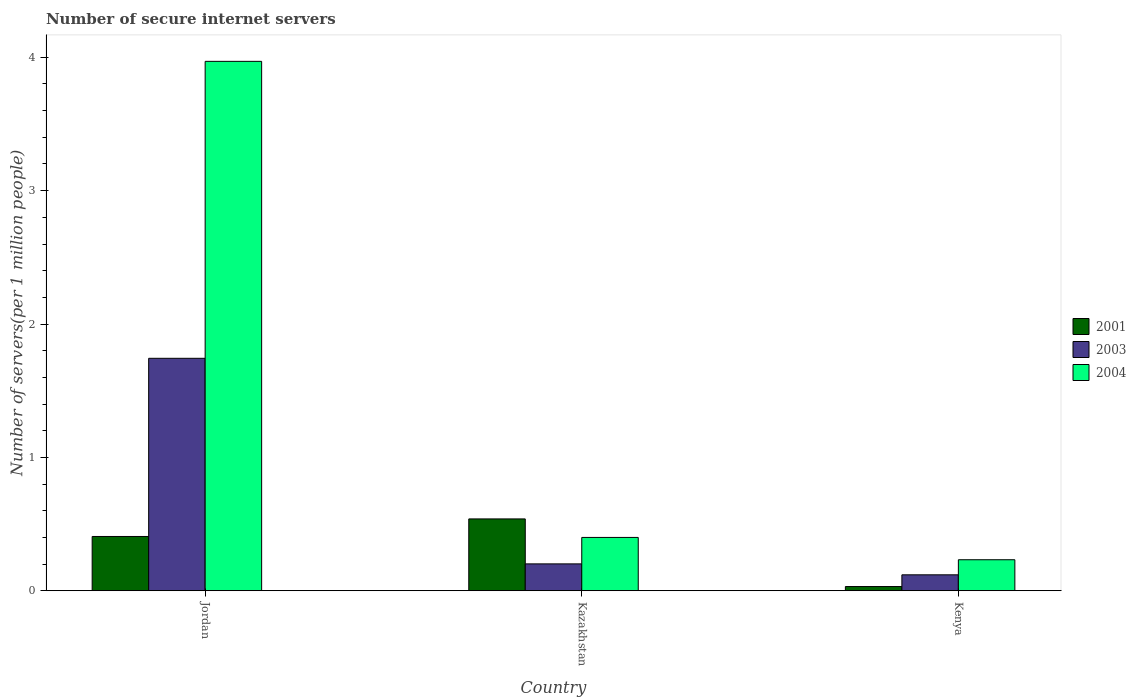How many groups of bars are there?
Your answer should be compact. 3. Are the number of bars on each tick of the X-axis equal?
Your answer should be compact. Yes. How many bars are there on the 2nd tick from the left?
Keep it short and to the point. 3. What is the label of the 1st group of bars from the left?
Provide a short and direct response. Jordan. What is the number of secure internet servers in 2004 in Kenya?
Provide a succinct answer. 0.23. Across all countries, what is the maximum number of secure internet servers in 2003?
Your answer should be compact. 1.74. Across all countries, what is the minimum number of secure internet servers in 2004?
Give a very brief answer. 0.23. In which country was the number of secure internet servers in 2003 maximum?
Your answer should be compact. Jordan. In which country was the number of secure internet servers in 2001 minimum?
Your response must be concise. Kenya. What is the total number of secure internet servers in 2003 in the graph?
Give a very brief answer. 2.06. What is the difference between the number of secure internet servers in 2004 in Jordan and that in Kenya?
Offer a terse response. 3.74. What is the difference between the number of secure internet servers in 2003 in Kenya and the number of secure internet servers in 2004 in Kazakhstan?
Your answer should be compact. -0.28. What is the average number of secure internet servers in 2003 per country?
Make the answer very short. 0.69. What is the difference between the number of secure internet servers of/in 2004 and number of secure internet servers of/in 2003 in Kazakhstan?
Provide a short and direct response. 0.2. What is the ratio of the number of secure internet servers in 2001 in Jordan to that in Kazakhstan?
Provide a succinct answer. 0.76. Is the difference between the number of secure internet servers in 2004 in Jordan and Kazakhstan greater than the difference between the number of secure internet servers in 2003 in Jordan and Kazakhstan?
Your response must be concise. Yes. What is the difference between the highest and the second highest number of secure internet servers in 2004?
Give a very brief answer. -3.57. What is the difference between the highest and the lowest number of secure internet servers in 2004?
Give a very brief answer. 3.74. Is it the case that in every country, the sum of the number of secure internet servers in 2004 and number of secure internet servers in 2001 is greater than the number of secure internet servers in 2003?
Provide a short and direct response. Yes. Are all the bars in the graph horizontal?
Provide a succinct answer. No. How many countries are there in the graph?
Offer a terse response. 3. What is the difference between two consecutive major ticks on the Y-axis?
Provide a short and direct response. 1. Does the graph contain any zero values?
Provide a short and direct response. No. Where does the legend appear in the graph?
Offer a very short reply. Center right. How are the legend labels stacked?
Your answer should be compact. Vertical. What is the title of the graph?
Ensure brevity in your answer.  Number of secure internet servers. What is the label or title of the Y-axis?
Offer a very short reply. Number of servers(per 1 million people). What is the Number of servers(per 1 million people) of 2001 in Jordan?
Provide a short and direct response. 0.41. What is the Number of servers(per 1 million people) in 2003 in Jordan?
Offer a very short reply. 1.74. What is the Number of servers(per 1 million people) in 2004 in Jordan?
Your answer should be very brief. 3.97. What is the Number of servers(per 1 million people) in 2001 in Kazakhstan?
Your answer should be very brief. 0.54. What is the Number of servers(per 1 million people) of 2003 in Kazakhstan?
Provide a short and direct response. 0.2. What is the Number of servers(per 1 million people) of 2004 in Kazakhstan?
Your answer should be compact. 0.4. What is the Number of servers(per 1 million people) of 2001 in Kenya?
Give a very brief answer. 0.03. What is the Number of servers(per 1 million people) in 2003 in Kenya?
Your answer should be very brief. 0.12. What is the Number of servers(per 1 million people) of 2004 in Kenya?
Your answer should be very brief. 0.23. Across all countries, what is the maximum Number of servers(per 1 million people) in 2001?
Offer a very short reply. 0.54. Across all countries, what is the maximum Number of servers(per 1 million people) in 2003?
Your answer should be very brief. 1.74. Across all countries, what is the maximum Number of servers(per 1 million people) of 2004?
Your answer should be very brief. 3.97. Across all countries, what is the minimum Number of servers(per 1 million people) of 2001?
Your answer should be very brief. 0.03. Across all countries, what is the minimum Number of servers(per 1 million people) in 2003?
Your answer should be very brief. 0.12. Across all countries, what is the minimum Number of servers(per 1 million people) of 2004?
Ensure brevity in your answer.  0.23. What is the total Number of servers(per 1 million people) in 2001 in the graph?
Your answer should be very brief. 0.98. What is the total Number of servers(per 1 million people) in 2003 in the graph?
Keep it short and to the point. 2.06. What is the total Number of servers(per 1 million people) of 2004 in the graph?
Ensure brevity in your answer.  4.6. What is the difference between the Number of servers(per 1 million people) of 2001 in Jordan and that in Kazakhstan?
Provide a short and direct response. -0.13. What is the difference between the Number of servers(per 1 million people) of 2003 in Jordan and that in Kazakhstan?
Ensure brevity in your answer.  1.54. What is the difference between the Number of servers(per 1 million people) of 2004 in Jordan and that in Kazakhstan?
Your answer should be very brief. 3.57. What is the difference between the Number of servers(per 1 million people) in 2001 in Jordan and that in Kenya?
Your response must be concise. 0.38. What is the difference between the Number of servers(per 1 million people) in 2003 in Jordan and that in Kenya?
Make the answer very short. 1.62. What is the difference between the Number of servers(per 1 million people) of 2004 in Jordan and that in Kenya?
Your answer should be compact. 3.74. What is the difference between the Number of servers(per 1 million people) in 2001 in Kazakhstan and that in Kenya?
Your answer should be very brief. 0.51. What is the difference between the Number of servers(per 1 million people) of 2003 in Kazakhstan and that in Kenya?
Keep it short and to the point. 0.08. What is the difference between the Number of servers(per 1 million people) in 2004 in Kazakhstan and that in Kenya?
Your answer should be compact. 0.17. What is the difference between the Number of servers(per 1 million people) in 2001 in Jordan and the Number of servers(per 1 million people) in 2003 in Kazakhstan?
Offer a very short reply. 0.21. What is the difference between the Number of servers(per 1 million people) in 2001 in Jordan and the Number of servers(per 1 million people) in 2004 in Kazakhstan?
Provide a succinct answer. 0.01. What is the difference between the Number of servers(per 1 million people) in 2003 in Jordan and the Number of servers(per 1 million people) in 2004 in Kazakhstan?
Your answer should be very brief. 1.34. What is the difference between the Number of servers(per 1 million people) in 2001 in Jordan and the Number of servers(per 1 million people) in 2003 in Kenya?
Offer a very short reply. 0.29. What is the difference between the Number of servers(per 1 million people) in 2001 in Jordan and the Number of servers(per 1 million people) in 2004 in Kenya?
Your response must be concise. 0.17. What is the difference between the Number of servers(per 1 million people) of 2003 in Jordan and the Number of servers(per 1 million people) of 2004 in Kenya?
Provide a succinct answer. 1.51. What is the difference between the Number of servers(per 1 million people) of 2001 in Kazakhstan and the Number of servers(per 1 million people) of 2003 in Kenya?
Your answer should be very brief. 0.42. What is the difference between the Number of servers(per 1 million people) in 2001 in Kazakhstan and the Number of servers(per 1 million people) in 2004 in Kenya?
Provide a short and direct response. 0.31. What is the difference between the Number of servers(per 1 million people) of 2003 in Kazakhstan and the Number of servers(per 1 million people) of 2004 in Kenya?
Provide a succinct answer. -0.03. What is the average Number of servers(per 1 million people) of 2001 per country?
Give a very brief answer. 0.33. What is the average Number of servers(per 1 million people) of 2003 per country?
Make the answer very short. 0.69. What is the average Number of servers(per 1 million people) in 2004 per country?
Offer a very short reply. 1.53. What is the difference between the Number of servers(per 1 million people) of 2001 and Number of servers(per 1 million people) of 2003 in Jordan?
Offer a very short reply. -1.34. What is the difference between the Number of servers(per 1 million people) of 2001 and Number of servers(per 1 million people) of 2004 in Jordan?
Your answer should be very brief. -3.56. What is the difference between the Number of servers(per 1 million people) in 2003 and Number of servers(per 1 million people) in 2004 in Jordan?
Your answer should be compact. -2.23. What is the difference between the Number of servers(per 1 million people) of 2001 and Number of servers(per 1 million people) of 2003 in Kazakhstan?
Provide a succinct answer. 0.34. What is the difference between the Number of servers(per 1 million people) of 2001 and Number of servers(per 1 million people) of 2004 in Kazakhstan?
Your response must be concise. 0.14. What is the difference between the Number of servers(per 1 million people) in 2003 and Number of servers(per 1 million people) in 2004 in Kazakhstan?
Your answer should be very brief. -0.2. What is the difference between the Number of servers(per 1 million people) in 2001 and Number of servers(per 1 million people) in 2003 in Kenya?
Offer a terse response. -0.09. What is the difference between the Number of servers(per 1 million people) of 2001 and Number of servers(per 1 million people) of 2004 in Kenya?
Offer a very short reply. -0.2. What is the difference between the Number of servers(per 1 million people) in 2003 and Number of servers(per 1 million people) in 2004 in Kenya?
Provide a short and direct response. -0.11. What is the ratio of the Number of servers(per 1 million people) in 2001 in Jordan to that in Kazakhstan?
Offer a terse response. 0.76. What is the ratio of the Number of servers(per 1 million people) of 2003 in Jordan to that in Kazakhstan?
Provide a succinct answer. 8.66. What is the ratio of the Number of servers(per 1 million people) of 2004 in Jordan to that in Kazakhstan?
Your answer should be compact. 9.93. What is the ratio of the Number of servers(per 1 million people) in 2001 in Jordan to that in Kenya?
Your response must be concise. 12.96. What is the ratio of the Number of servers(per 1 million people) of 2003 in Jordan to that in Kenya?
Provide a succinct answer. 14.62. What is the ratio of the Number of servers(per 1 million people) in 2004 in Jordan to that in Kenya?
Offer a very short reply. 17.09. What is the ratio of the Number of servers(per 1 million people) in 2001 in Kazakhstan to that in Kenya?
Ensure brevity in your answer.  17.16. What is the ratio of the Number of servers(per 1 million people) of 2003 in Kazakhstan to that in Kenya?
Ensure brevity in your answer.  1.69. What is the ratio of the Number of servers(per 1 million people) of 2004 in Kazakhstan to that in Kenya?
Ensure brevity in your answer.  1.72. What is the difference between the highest and the second highest Number of servers(per 1 million people) in 2001?
Ensure brevity in your answer.  0.13. What is the difference between the highest and the second highest Number of servers(per 1 million people) in 2003?
Your answer should be compact. 1.54. What is the difference between the highest and the second highest Number of servers(per 1 million people) of 2004?
Keep it short and to the point. 3.57. What is the difference between the highest and the lowest Number of servers(per 1 million people) of 2001?
Your answer should be very brief. 0.51. What is the difference between the highest and the lowest Number of servers(per 1 million people) of 2003?
Ensure brevity in your answer.  1.62. What is the difference between the highest and the lowest Number of servers(per 1 million people) of 2004?
Your response must be concise. 3.74. 